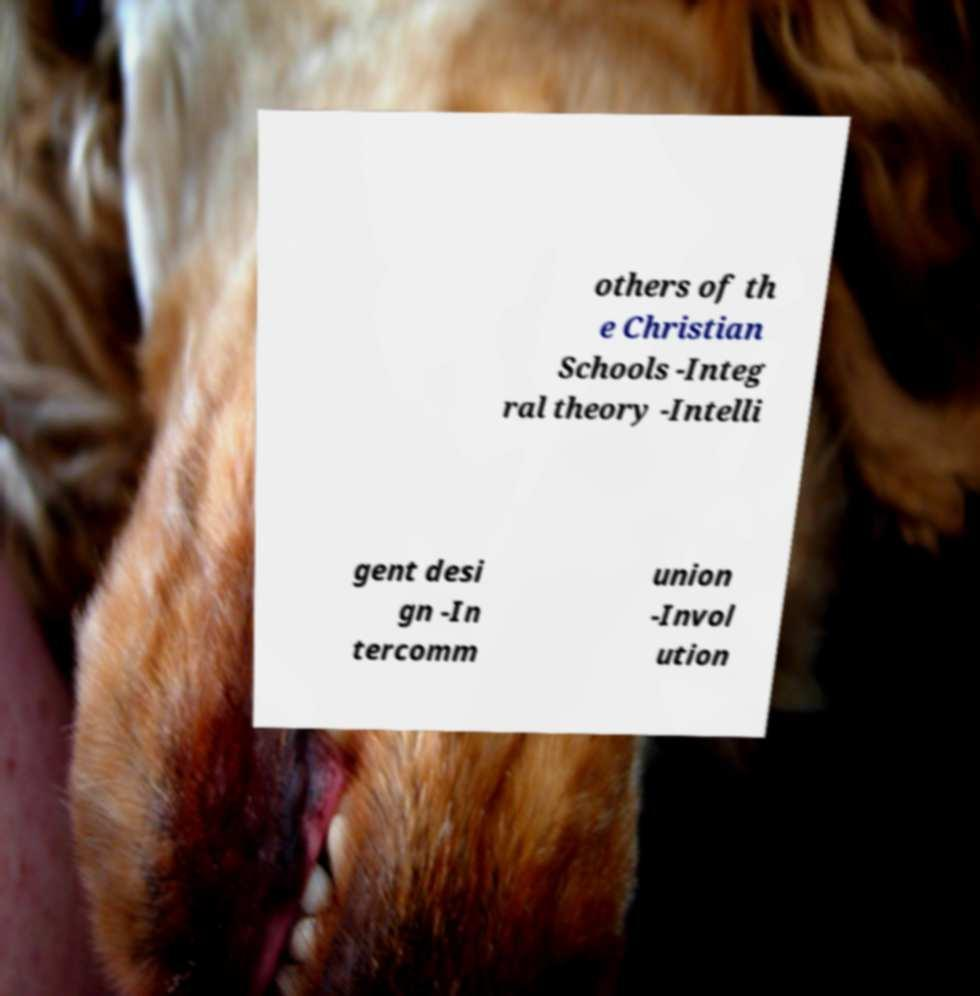Can you read and provide the text displayed in the image?This photo seems to have some interesting text. Can you extract and type it out for me? others of th e Christian Schools -Integ ral theory -Intelli gent desi gn -In tercomm union -Invol ution 